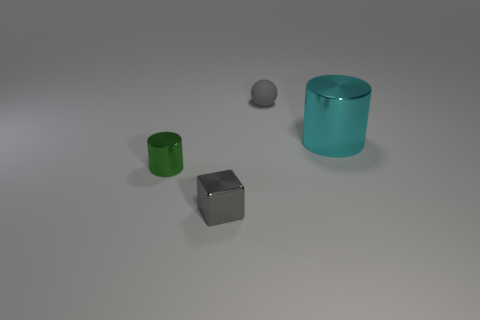Is there any other thing that has the same size as the cyan metal thing?
Ensure brevity in your answer.  No. Is there anything else that is made of the same material as the tiny gray ball?
Offer a very short reply. No. What number of tiny gray things have the same material as the green object?
Provide a short and direct response. 1. How many small metal cylinders are the same color as the small block?
Provide a short and direct response. 0. What number of things are either objects that are to the left of the rubber ball or gray objects on the right side of the tiny gray metal cube?
Your answer should be compact. 3. Are there fewer large shiny cylinders behind the matte sphere than small shiny cubes?
Your answer should be compact. Yes. Are there any green shiny cylinders of the same size as the cyan thing?
Offer a very short reply. No. What color is the metallic block?
Your answer should be compact. Gray. Do the cyan thing and the gray shiny object have the same size?
Provide a short and direct response. No. What number of objects are purple metallic balls or large metallic things?
Provide a short and direct response. 1. 